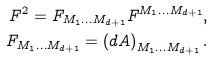Convert formula to latex. <formula><loc_0><loc_0><loc_500><loc_500>F ^ { 2 } = F _ { M _ { 1 } \dots M _ { d + 1 } } F ^ { M _ { 1 } \dots M _ { d + 1 } } , \\ F _ { M _ { 1 } \dots M _ { d + 1 } } = \left ( d A \right ) _ { M _ { 1 } \dots M _ { d + 1 } } .</formula> 